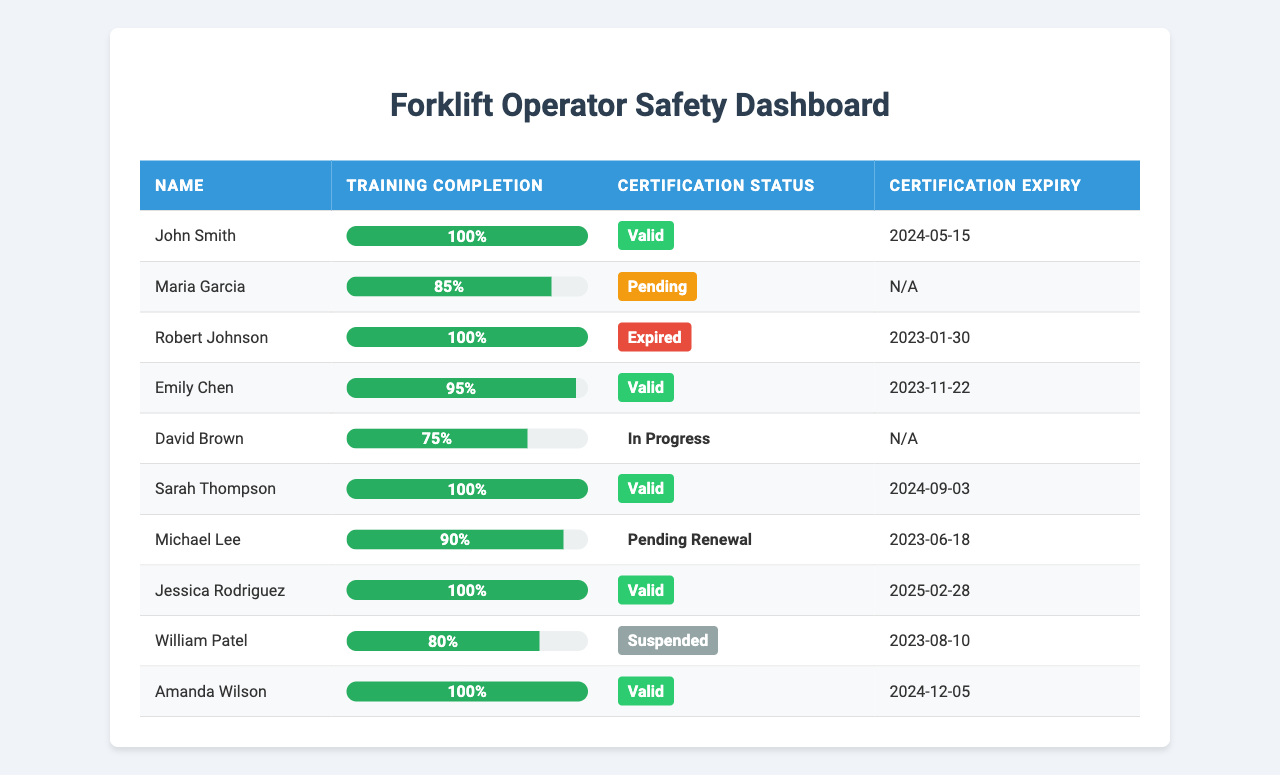What is the training completion rate of John Smith? John Smith has a training completion percentage listed in the table, which shows 100%.
Answer: 100% How many operators have a certification status of "Valid"? By checking the certification status column, there are 5 operators with a status of "Valid": John Smith, Emily Chen, Sarah Thompson, Jessica Rodriguez, and Amanda Wilson.
Answer: 5 What is the certification expiry date for Jessica Rodriguez? Looking at the certification expiry column for Jessica Rodriguez, it shows "2025-02-28."
Answer: 2025-02-28 What is the total number of operators with an expired certification status? The table indicates that Robert Johnson has an "Expired" certification status. Thus, there is only 1 operator in this category.
Answer: 1 Are there any operators with a training completion rate below 80%? Upon reviewing the training completion rates, David Brown has a rate of 75%, indicating one operator is below 80%.
Answer: Yes What is the average training completion rate of all operators listed? To calculate the average: sum the completion rates (100 + 85 + 100 + 95 + 75 + 100 + 90 + 100 + 80 + 100 = 1025) and divide by the number of operators (10). Therefore, the average is 1025 / 10 = 102.5.
Answer: 102.5 Which operator has the highest training completion rate? John Smith, Maria Garcia, Robert Johnson, Sarah Thompson, and Amanda Wilson have the highest completion rate, which is 100%.
Answer: John Smith, Sarah Thompson, and Amanda Wilson (tied) What percentage of operators have either a "Pending" or "In Progress" certification status? The operators Maria Garcia (Pending) and David Brown (In Progress) sum up to 2 operators out of 10 total, calculating the percentage gives (2/10) * 100 = 20%.
Answer: 20% Does William Patel have a valid certification status? The certification status column for William Patel indicates "Suspended," which is not valid; therefore, the answer is no.
Answer: No How many operators need a certification renewal based on the data? The certification status of Michael Lee shows "Pending Renewal", indicating he needs renewal, making it one operator in total.
Answer: 1 